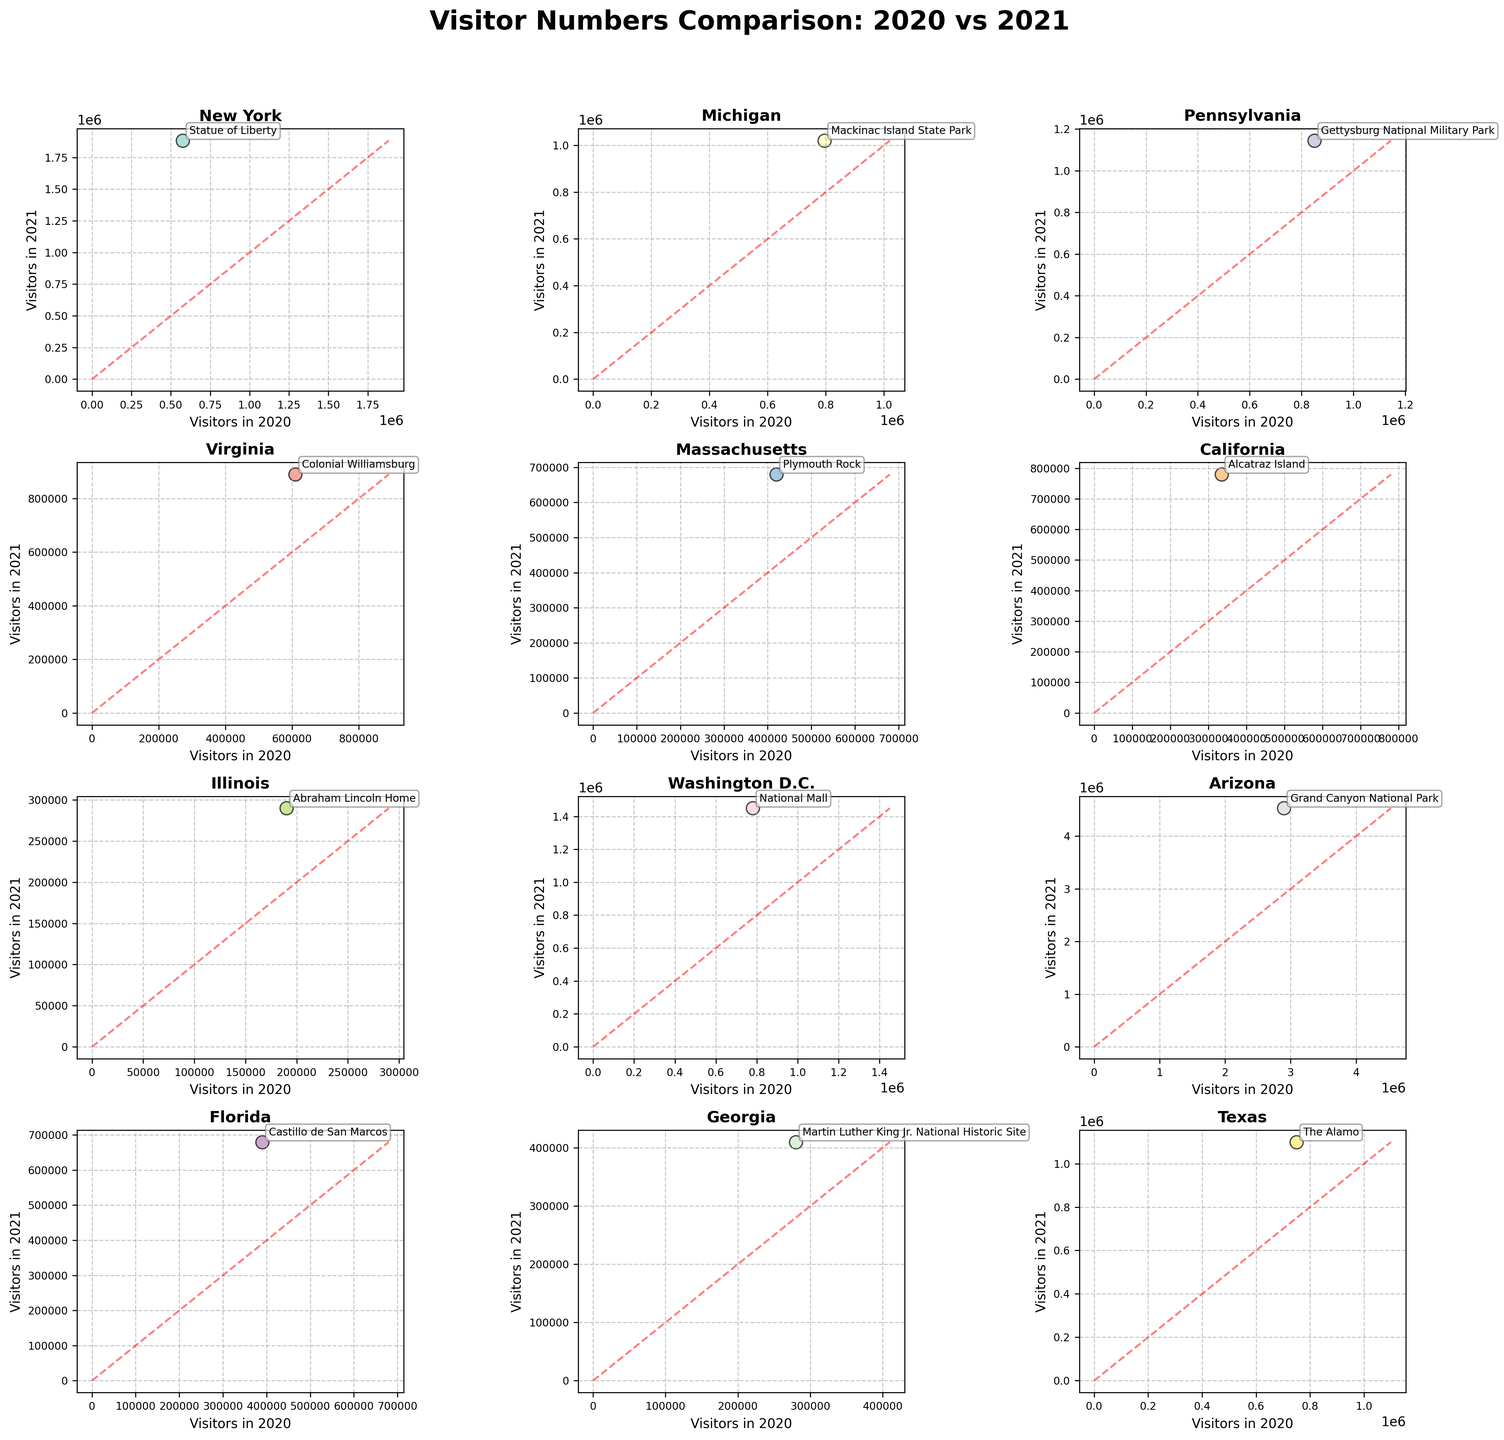What is the title of the figure? The title is displayed at the top of the figure. It conveys the purpose or subject of the data being presented.
Answer: Visitor Numbers Comparison: 2020 vs 2021 How many scatter plots are in the figure? To determine the number of scatter plots, count the total number of individual plots within the figure. Each plot represents data from a different state.
Answer: 12 Which state had the highest number of visitors in 2021 and what is the site? By comparing the y-axes of all subplots (representing Visitors in 2021), identify the highest value and the corresponding state and site. The Grand Canyon National Park in Arizona has the highest number of visitors in 2021.
Answer: Arizona, Grand Canyon National Park Which historical site in New York had the greatest increase in visitors from 2020 to 2021? To find the site with the greatest increase in New York, subtract the number of Visitors in 2020 from Visitors in 2021 for the site's scatter plot. Statue of Liberty had the greatest increase in visitors in New York.
Answer: Statue of Liberty How does the trend line (red dashed line) function in the subplots? The red dashed line represents a theoretical line where the number of visitors in 2020 is equal to the number of visitors in 2021. It helps in comparing how the visitor numbers changed over the years. If points lie above the line, visitors increased in 2021; if below, they decreased.
Answer: It shows visitor increase or decrease Which state saw a visitor number below the red dashed line and which site is it? Identify points that are below the red dashed line in their respective scatter plots, which means there were fewer visitors in 2021 compared to 2020.
Answer: No state has visitor numbers below the red dashed line How many states show more visitors in 2021 than in 2020? The points above the red dashed line in their respective scatter plots indicate more visitors in 2021 than in 2020. Count these points.
Answer: 12 Which states had visitor numbers closest to each other in 2020 and 2021? Locate the scatter plots where the points lie closest to the red dashed line, indicating similar visitor numbers in both years.
Answer: Illinois (Abraham Lincoln Home) Which historical site had a visitor count of approximately 680,000 in 2021 and which state is it in? By checking the y-axis (Visitors in 2021) in each scatter plot, find the points that match up with 680,000 visitors, noting the site and state. Castillo de San Marcos in Florida and Plymouth Rock in Massachusetts each had approximately 680,000 visitors.
Answer: Castillo de San Marcos, Florida; Plymouth Rock, Massachusetts 